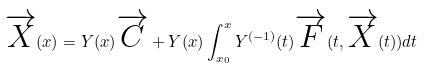<formula> <loc_0><loc_0><loc_500><loc_500>\overrightarrow { X } ( x ) = Y ( x ) \overrightarrow { C } + Y ( x ) \int _ { x _ { 0 } } ^ { x } Y ^ { ( - 1 ) } ( t ) \overrightarrow { F } ( t , \overrightarrow { X } ( t ) ) d t</formula> 